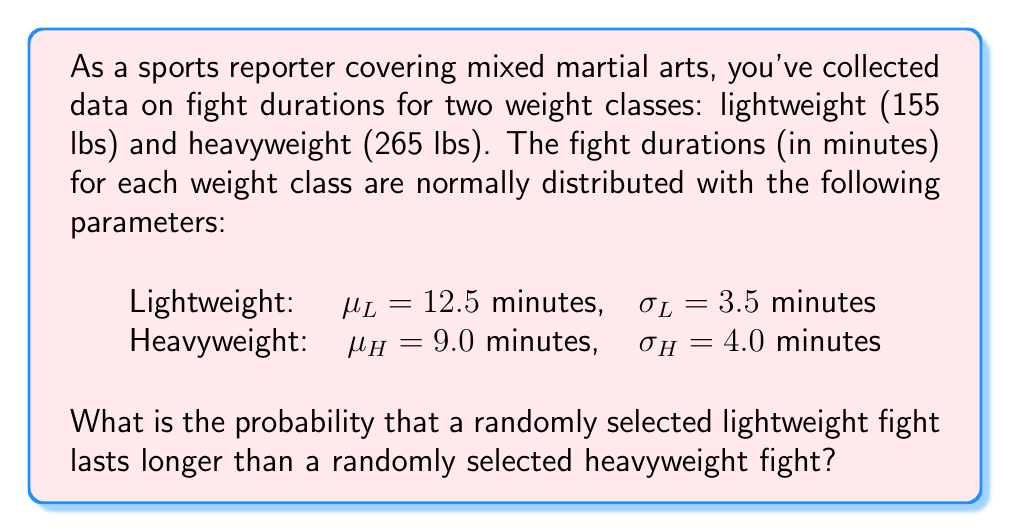Show me your answer to this math problem. To solve this problem, we need to find the probability that the difference between a lightweight fight duration ($X_L$) and a heavyweight fight duration ($X_H$) is greater than zero.

Let $Y = X_L - X_H$ be the difference between the two fight durations.

Since both $X_L$ and $X_H$ are normally distributed, their difference $Y$ is also normally distributed. We need to find the mean and standard deviation of $Y$.

1. Calculate the mean of $Y$:
   $$\mu_Y = \mu_L - \mu_H = 12.5 - 9.0 = 3.5\text{ minutes}$$

2. Calculate the variance of $Y$:
   $$\sigma_Y^2 = \sigma_L^2 + \sigma_H^2 = 3.5^2 + 4.0^2 = 12.25 + 16 = 28.25$$

3. Calculate the standard deviation of $Y$:
   $$\sigma_Y = \sqrt{28.25} = 5.315\text{ minutes}$$

4. We want to find $P(Y > 0)$, which is equivalent to finding the probability that a standard normal variable $Z$ is greater than $-\mu_Y / \sigma_Y$:

   $$P(Y > 0) = P(Z > -\mu_Y / \sigma_Y) = P(Z > -3.5 / 5.315) = P(Z > -0.658)$$

5. Using a standard normal table or calculator, we find:
   $$P(Z > -0.658) = 1 - P(Z < -0.658) = 1 - 0.2551 = 0.7449$$

Therefore, the probability that a randomly selected lightweight fight lasts longer than a randomly selected heavyweight fight is approximately 0.7449 or 74.49%.
Answer: 0.7449 or 74.49% 